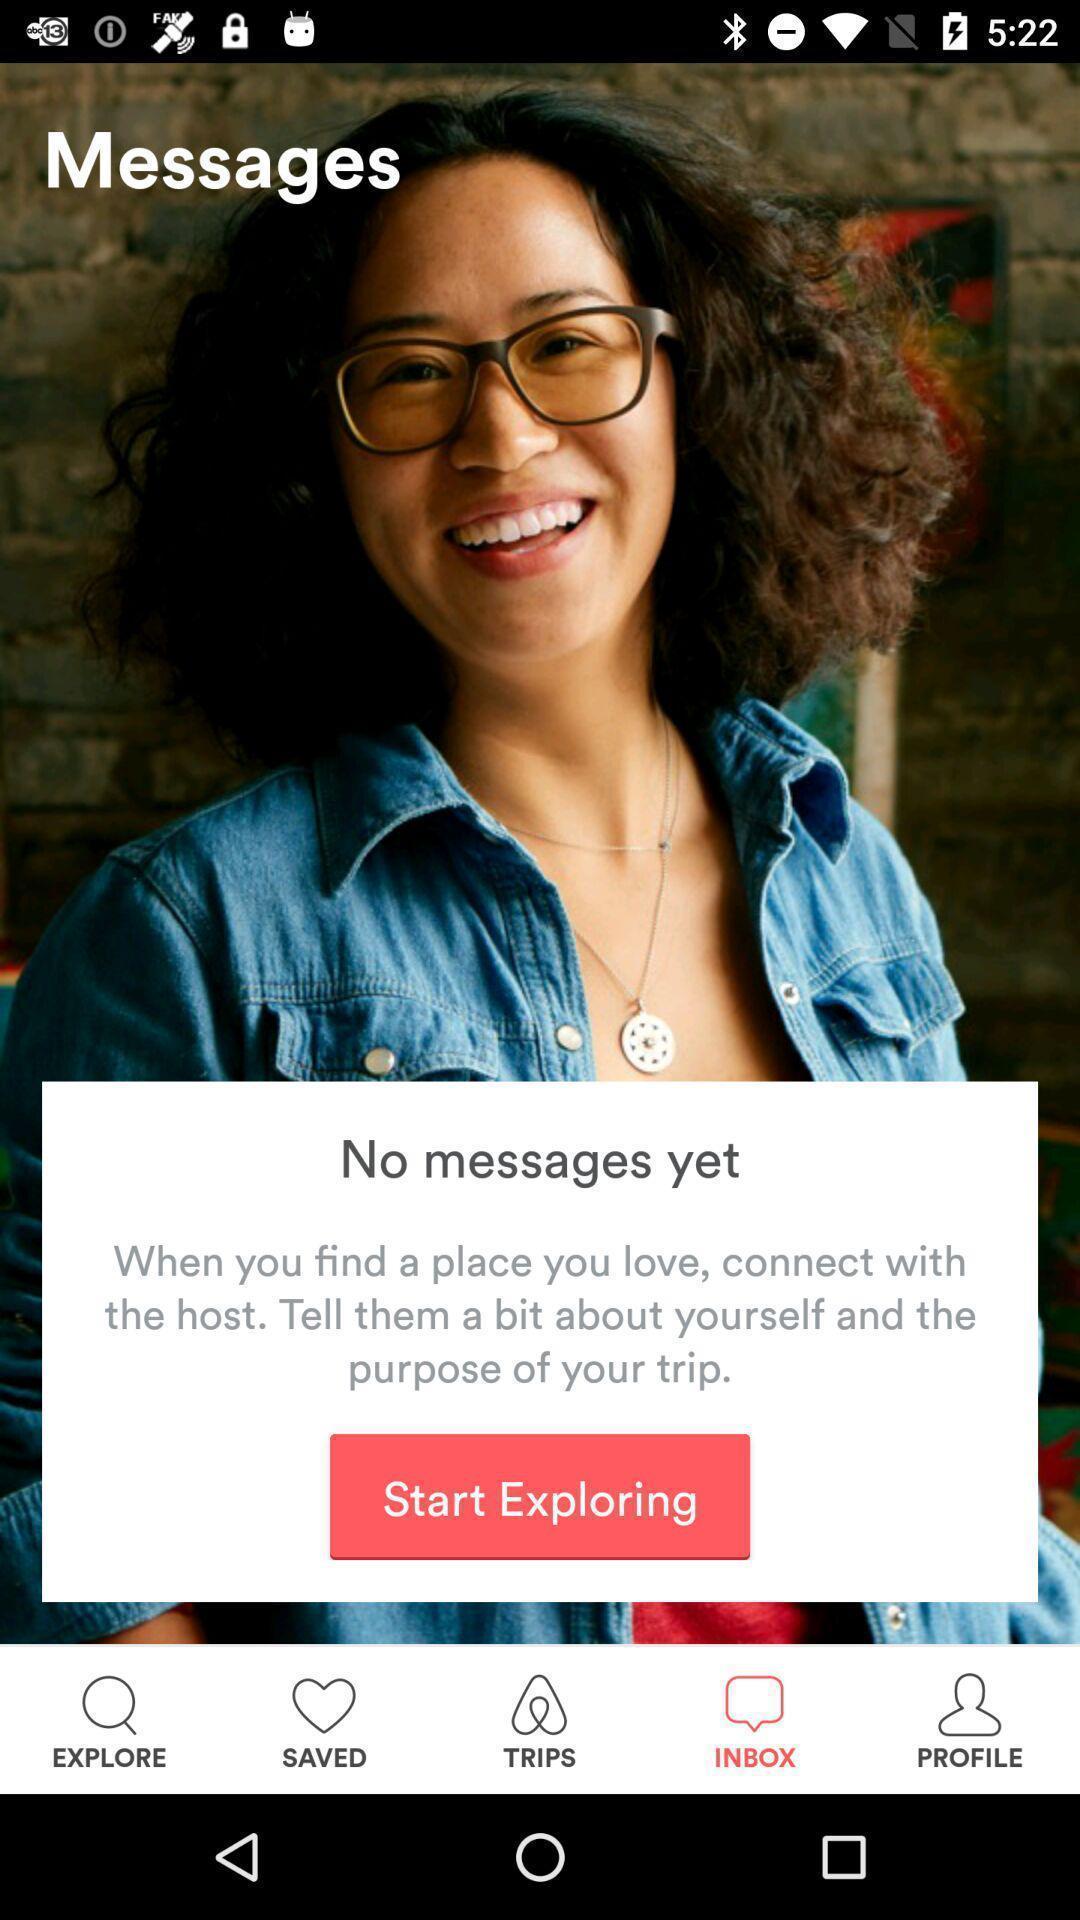What details can you identify in this image? Welcome page for a social app. 